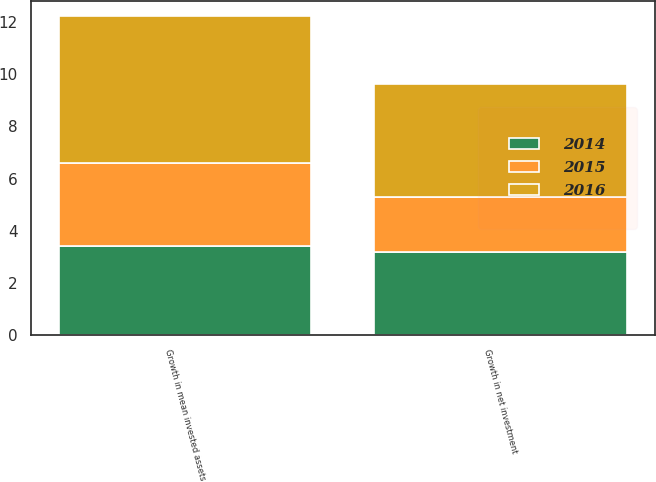<chart> <loc_0><loc_0><loc_500><loc_500><stacked_bar_chart><ecel><fcel>Growth in net investment<fcel>Growth in mean invested assets<nl><fcel>2016<fcel>4.3<fcel>5.6<nl><fcel>2015<fcel>2.1<fcel>3.2<nl><fcel>2014<fcel>3.2<fcel>3.4<nl></chart> 